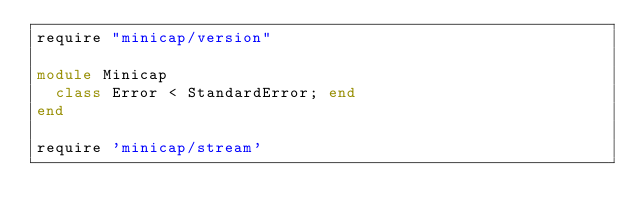Convert code to text. <code><loc_0><loc_0><loc_500><loc_500><_Ruby_>require "minicap/version"

module Minicap
  class Error < StandardError; end
end

require 'minicap/stream'
</code> 